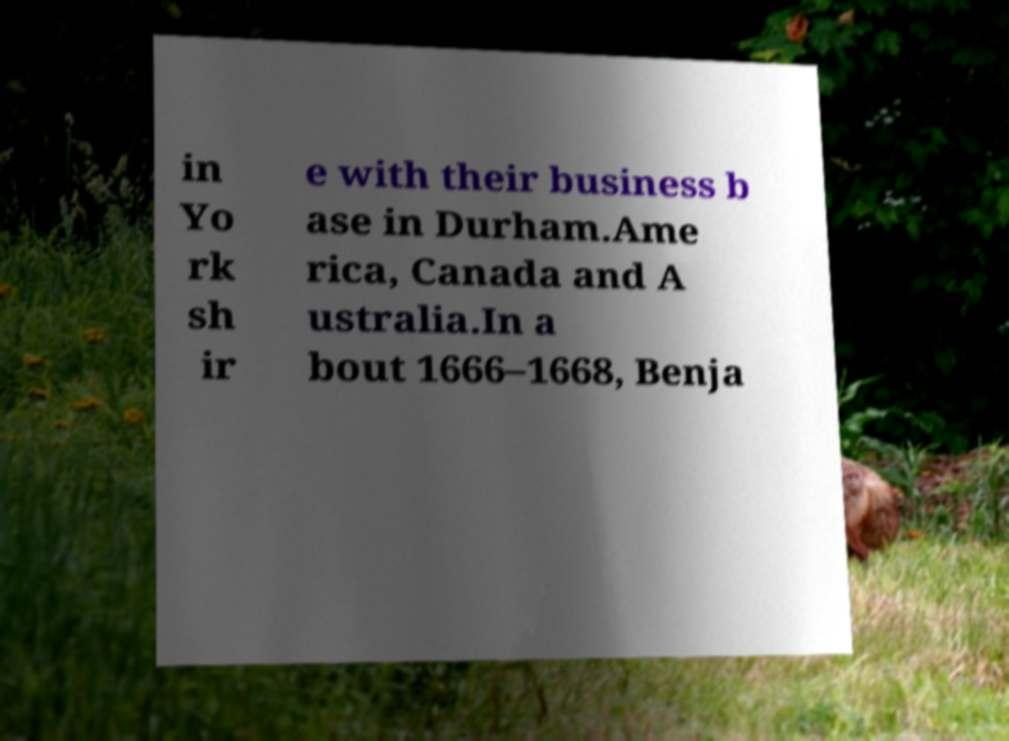Could you assist in decoding the text presented in this image and type it out clearly? in Yo rk sh ir e with their business b ase in Durham.Ame rica, Canada and A ustralia.In a bout 1666–1668, Benja 